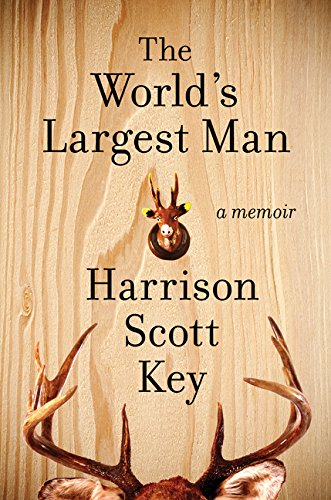What type of book is this? This book falls under the Humor & Entertainment category, focusing on the amusing and sometimes poignant tales from the author's life. 